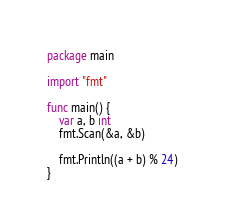<code> <loc_0><loc_0><loc_500><loc_500><_Go_>package main

import "fmt"

func main() {
	var a, b int
	fmt.Scan(&a, &b)

	fmt.Println((a + b) % 24)
}
</code> 